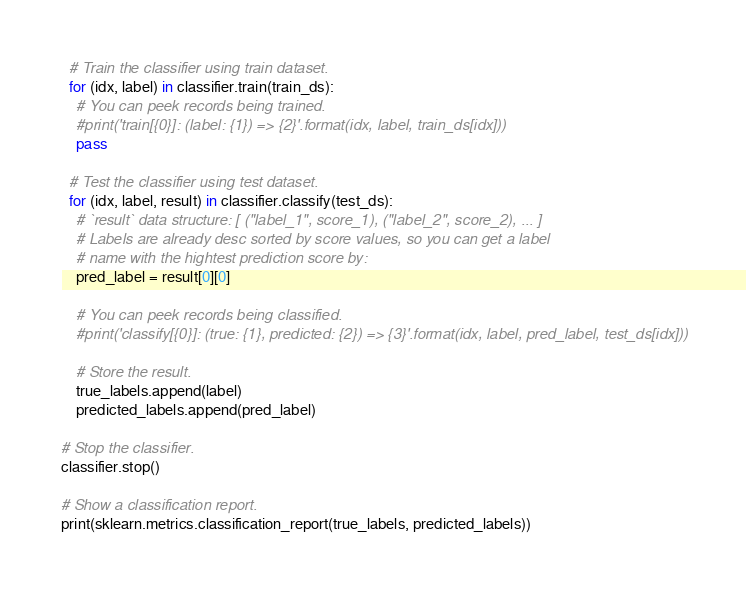<code> <loc_0><loc_0><loc_500><loc_500><_Python_>
  # Train the classifier using train dataset.
  for (idx, label) in classifier.train(train_ds):
    # You can peek records being trained.
    #print('train[{0}]: (label: {1}) => {2}'.format(idx, label, train_ds[idx]))
    pass

  # Test the classifier using test dataset.
  for (idx, label, result) in classifier.classify(test_ds):
    # `result` data structure: [ ("label_1", score_1), ("label_2", score_2), ... ]
    # Labels are already desc sorted by score values, so you can get a label
    # name with the hightest prediction score by:
    pred_label = result[0][0]

    # You can peek records being classified.
    #print('classify[{0}]: (true: {1}, predicted: {2}) => {3}'.format(idx, label, pred_label, test_ds[idx]))

    # Store the result.
    true_labels.append(label)
    predicted_labels.append(pred_label)

# Stop the classifier.
classifier.stop()

# Show a classification report.
print(sklearn.metrics.classification_report(true_labels, predicted_labels))
</code> 